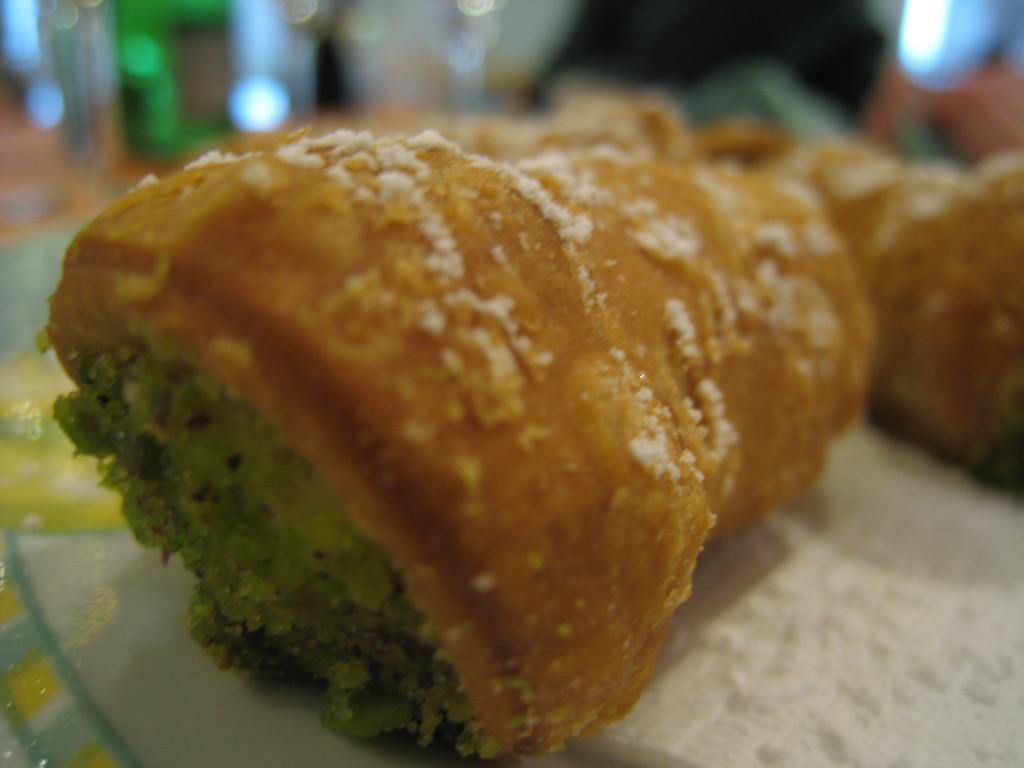Can you describe this image briefly? This image consists of food and the background is blurry. 